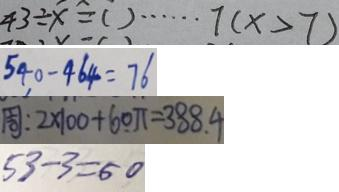<formula> <loc_0><loc_0><loc_500><loc_500>4 3 \div x = ( ) \cdots 7 ( x > 7 ) 
 5 4 0 - 4 6 4 = 7 6 
 周 : 2 \times 1 0 0 + 6 0 \pi = 3 8 8 . 4 
 5 3 - 3 = 5 0</formula> 